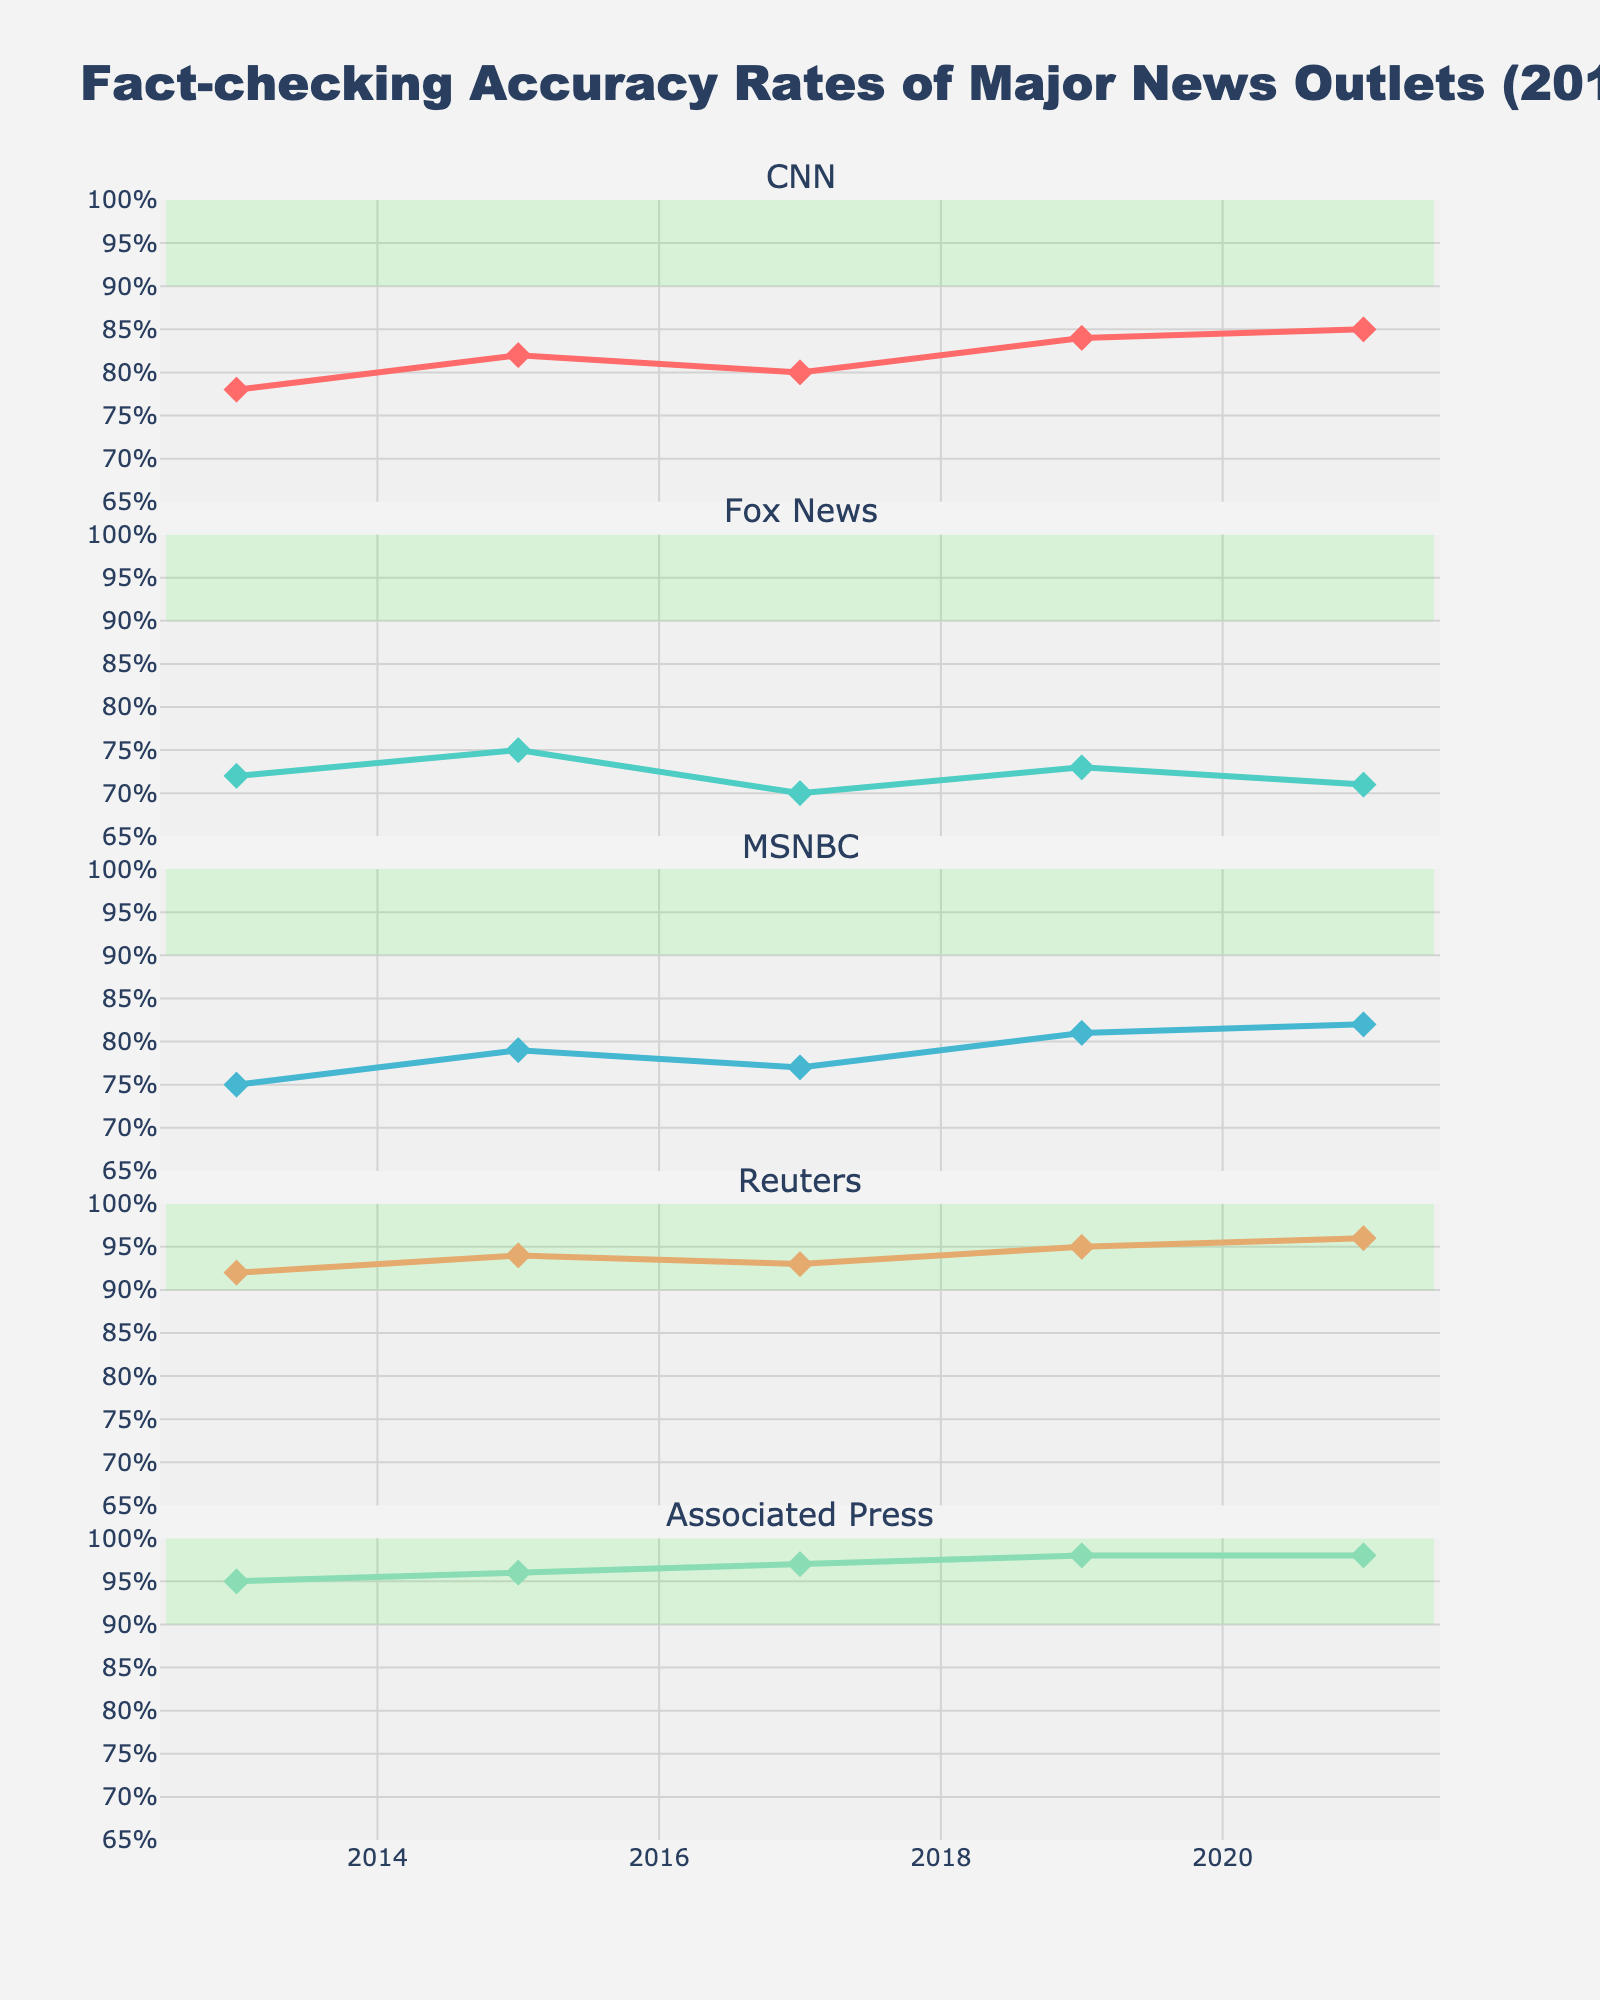What is the title of the plot? The title is found at the top of the figure, indicating what the figure is about.
Answer: Fact-checking Accuracy Rates of Major News Outlets (2013-2021) What is the range of accuracy rates shown on the y-axis? The y-axis range can be observed on the left side of each subplot.
Answer: 65% to 100% Which news outlet consistently has the highest accuracy rate according to the plot? By looking at the subplots, we see that Reuters and Associated Press generally have the highest accuracy rates in their respective subplots.
Answer: Reuters and Associated Press What is the trend in CNN's fact-checking accuracy from 2013 to 2021? Observing CNN's line in its subplot, we see that the accuracy rate increases over time.
Answer: Increasing How do Reuters' and Associated Press' accuracy rates compare in 2021? By comparing the y-values in the subplots of Reuters and Associated Press for the year 2021, we see that they both have similar high accuracy rates.
Answer: Essentially the same (96% for Reuters, 98% for Associated Press) What is the average accuracy rate for Fox News over the years shown in the plot? Adding up all the accuracy rates for Fox News and dividing by the number of years gives us the average: (72 + 75 + 70 + 73 + 71) / 5.
Answer: 72.2% Which news outlet showed the most improvement in accuracy rate from 2013 to 2021? Comparing the beginning and ending points for each news outlet, CNN shows significant improvement from 78% in 2013 to 85% in 2021.
Answer: CNN What is the difference in MSNBC's accuracy rate between 2013 and 2021? Subtract 75% (accuracy in 2013) from 82% (accuracy in 2021).
Answer: 7% How did the accuracy rates of MSNBC and Fox News compare in 2019? By looking at the values in the respective subplots for the year 2019, MSNBC had an accuracy rate of 81%, while Fox News had 73%.
Answer: MSNBC had higher accuracy What is the range of accuracy rates for Associated Press over the years shown in the plot? The range is determined by subtracting the smallest value (95% in 2013) from the largest value (98% in 2017 and 2021).
Answer: 3% 